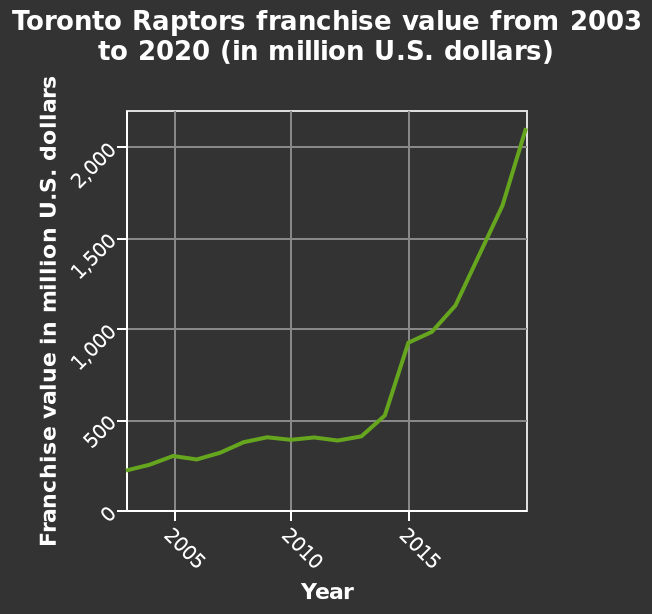<image>
In which year did the franchise value reach the highest point in the line plot? The line plot does not provide information about the specific year when the franchise value reached its highest point. What is the range of the y-axis in the line plot?  The range of the y-axis is from 0 to 2,000 million U.S. dollars. Did the line plot provide information about the specific year when the franchise value reached its highest point? No.The line plot does not provide information about the specific year when the franchise value reached its highest point. 